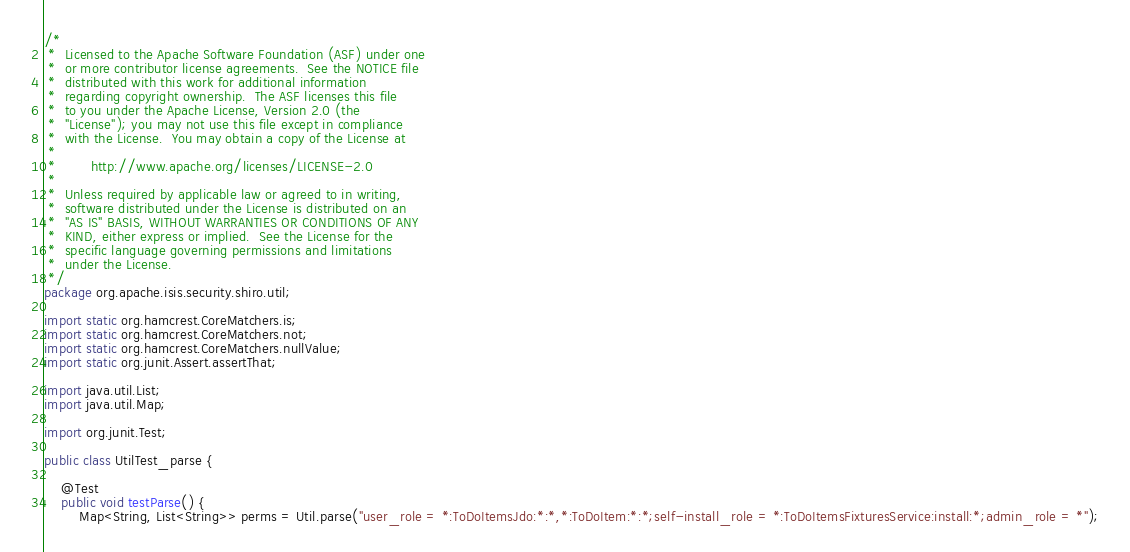Convert code to text. <code><loc_0><loc_0><loc_500><loc_500><_Java_>/*
 *  Licensed to the Apache Software Foundation (ASF) under one
 *  or more contributor license agreements.  See the NOTICE file
 *  distributed with this work for additional information
 *  regarding copyright ownership.  The ASF licenses this file
 *  to you under the Apache License, Version 2.0 (the
 *  "License"); you may not use this file except in compliance
 *  with the License.  You may obtain a copy of the License at
 *
 *        http://www.apache.org/licenses/LICENSE-2.0
 *
 *  Unless required by applicable law or agreed to in writing,
 *  software distributed under the License is distributed on an
 *  "AS IS" BASIS, WITHOUT WARRANTIES OR CONDITIONS OF ANY
 *  KIND, either express or implied.  See the License for the
 *  specific language governing permissions and limitations
 *  under the License.
 */
package org.apache.isis.security.shiro.util;

import static org.hamcrest.CoreMatchers.is;
import static org.hamcrest.CoreMatchers.not;
import static org.hamcrest.CoreMatchers.nullValue;
import static org.junit.Assert.assertThat;

import java.util.List;
import java.util.Map;

import org.junit.Test;

public class UtilTest_parse {

    @Test
    public void testParse() {
        Map<String, List<String>> perms = Util.parse("user_role = *:ToDoItemsJdo:*:*,*:ToDoItem:*:*;self-install_role = *:ToDoItemsFixturesService:install:*;admin_role = *");</code> 